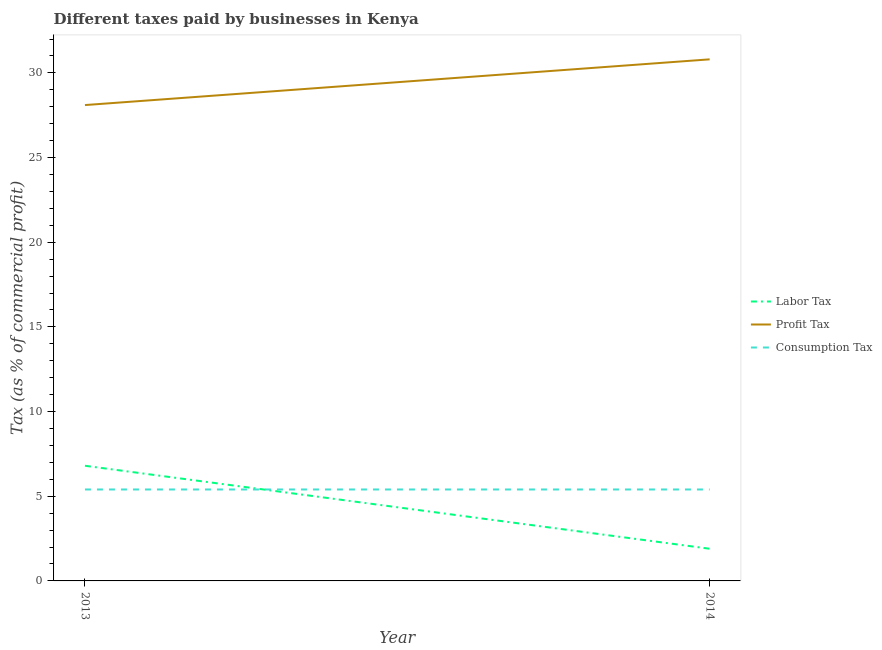Does the line corresponding to percentage of consumption tax intersect with the line corresponding to percentage of profit tax?
Give a very brief answer. No. Is the number of lines equal to the number of legend labels?
Make the answer very short. Yes. What is the percentage of consumption tax in 2013?
Give a very brief answer. 5.4. Across all years, what is the maximum percentage of profit tax?
Ensure brevity in your answer.  30.8. What is the total percentage of consumption tax in the graph?
Offer a very short reply. 10.8. What is the difference between the percentage of profit tax in 2013 and that in 2014?
Ensure brevity in your answer.  -2.7. What is the difference between the percentage of labor tax in 2013 and the percentage of profit tax in 2014?
Give a very brief answer. -24. What is the average percentage of consumption tax per year?
Provide a succinct answer. 5.4. In the year 2013, what is the difference between the percentage of consumption tax and percentage of labor tax?
Ensure brevity in your answer.  -1.4. What is the ratio of the percentage of profit tax in 2013 to that in 2014?
Provide a succinct answer. 0.91. In how many years, is the percentage of consumption tax greater than the average percentage of consumption tax taken over all years?
Your response must be concise. 0. Is the percentage of labor tax strictly less than the percentage of profit tax over the years?
Provide a succinct answer. Yes. What is the difference between two consecutive major ticks on the Y-axis?
Offer a very short reply. 5. Are the values on the major ticks of Y-axis written in scientific E-notation?
Your response must be concise. No. Does the graph contain any zero values?
Provide a succinct answer. No. Does the graph contain grids?
Provide a succinct answer. No. Where does the legend appear in the graph?
Provide a short and direct response. Center right. What is the title of the graph?
Your response must be concise. Different taxes paid by businesses in Kenya. What is the label or title of the X-axis?
Your answer should be very brief. Year. What is the label or title of the Y-axis?
Offer a very short reply. Tax (as % of commercial profit). What is the Tax (as % of commercial profit) in Labor Tax in 2013?
Provide a succinct answer. 6.8. What is the Tax (as % of commercial profit) of Profit Tax in 2013?
Give a very brief answer. 28.1. What is the Tax (as % of commercial profit) in Labor Tax in 2014?
Make the answer very short. 1.9. What is the Tax (as % of commercial profit) of Profit Tax in 2014?
Ensure brevity in your answer.  30.8. Across all years, what is the maximum Tax (as % of commercial profit) of Profit Tax?
Ensure brevity in your answer.  30.8. Across all years, what is the maximum Tax (as % of commercial profit) of Consumption Tax?
Provide a succinct answer. 5.4. Across all years, what is the minimum Tax (as % of commercial profit) of Profit Tax?
Give a very brief answer. 28.1. Across all years, what is the minimum Tax (as % of commercial profit) in Consumption Tax?
Provide a short and direct response. 5.4. What is the total Tax (as % of commercial profit) in Profit Tax in the graph?
Provide a short and direct response. 58.9. What is the difference between the Tax (as % of commercial profit) in Labor Tax in 2013 and that in 2014?
Keep it short and to the point. 4.9. What is the difference between the Tax (as % of commercial profit) of Labor Tax in 2013 and the Tax (as % of commercial profit) of Profit Tax in 2014?
Give a very brief answer. -24. What is the difference between the Tax (as % of commercial profit) of Profit Tax in 2013 and the Tax (as % of commercial profit) of Consumption Tax in 2014?
Keep it short and to the point. 22.7. What is the average Tax (as % of commercial profit) of Labor Tax per year?
Your response must be concise. 4.35. What is the average Tax (as % of commercial profit) in Profit Tax per year?
Give a very brief answer. 29.45. What is the average Tax (as % of commercial profit) in Consumption Tax per year?
Offer a very short reply. 5.4. In the year 2013, what is the difference between the Tax (as % of commercial profit) in Labor Tax and Tax (as % of commercial profit) in Profit Tax?
Make the answer very short. -21.3. In the year 2013, what is the difference between the Tax (as % of commercial profit) of Profit Tax and Tax (as % of commercial profit) of Consumption Tax?
Your response must be concise. 22.7. In the year 2014, what is the difference between the Tax (as % of commercial profit) of Labor Tax and Tax (as % of commercial profit) of Profit Tax?
Keep it short and to the point. -28.9. In the year 2014, what is the difference between the Tax (as % of commercial profit) in Profit Tax and Tax (as % of commercial profit) in Consumption Tax?
Your answer should be very brief. 25.4. What is the ratio of the Tax (as % of commercial profit) of Labor Tax in 2013 to that in 2014?
Your answer should be compact. 3.58. What is the ratio of the Tax (as % of commercial profit) in Profit Tax in 2013 to that in 2014?
Ensure brevity in your answer.  0.91. What is the difference between the highest and the second highest Tax (as % of commercial profit) of Profit Tax?
Your answer should be compact. 2.7. What is the difference between the highest and the second highest Tax (as % of commercial profit) of Consumption Tax?
Your answer should be compact. 0. What is the difference between the highest and the lowest Tax (as % of commercial profit) in Labor Tax?
Give a very brief answer. 4.9. What is the difference between the highest and the lowest Tax (as % of commercial profit) in Consumption Tax?
Give a very brief answer. 0. 